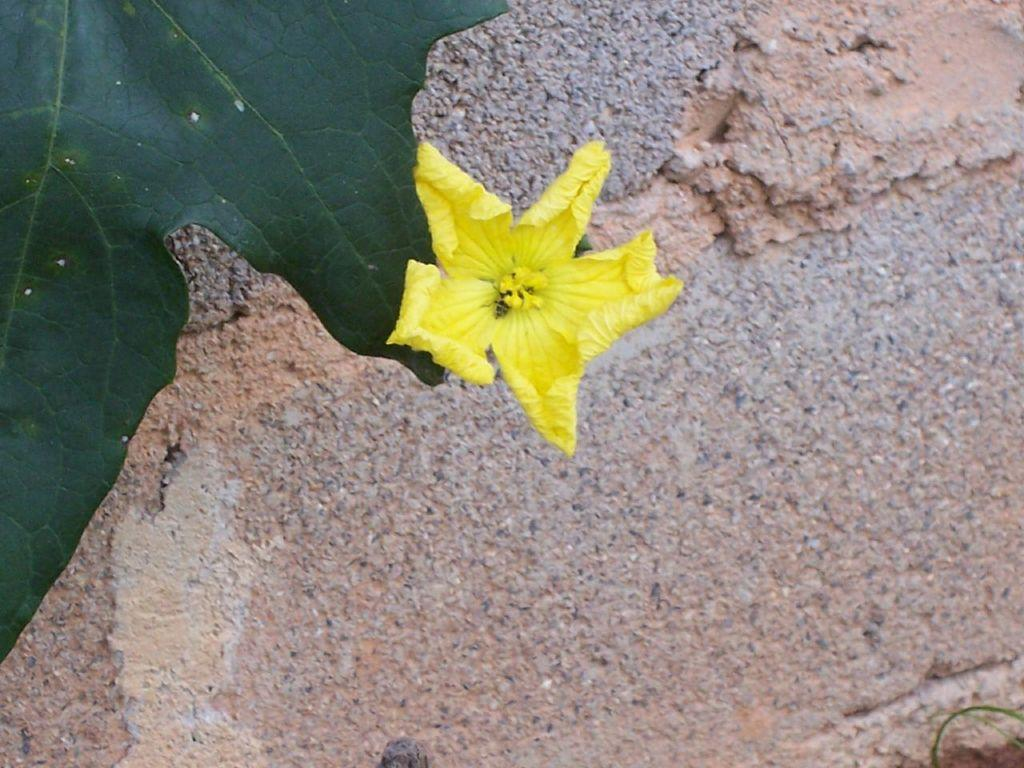What type of plant can be seen in the image? There is a flower in the image. What color is the flower? The flower is yellow. What other part of the plant is visible in the image? There is a green leaf in the image. What can be seen in the background of the image? There is a wall made of stones in the background of the image. How many wristwatches are visible on the flower in the image? There are no wristwatches present on the flower in the image. Is there a bike leaning against the stone wall in the background of the image? There is no bike visible in the image; only the flower, leaf, and stone wall can be seen. 